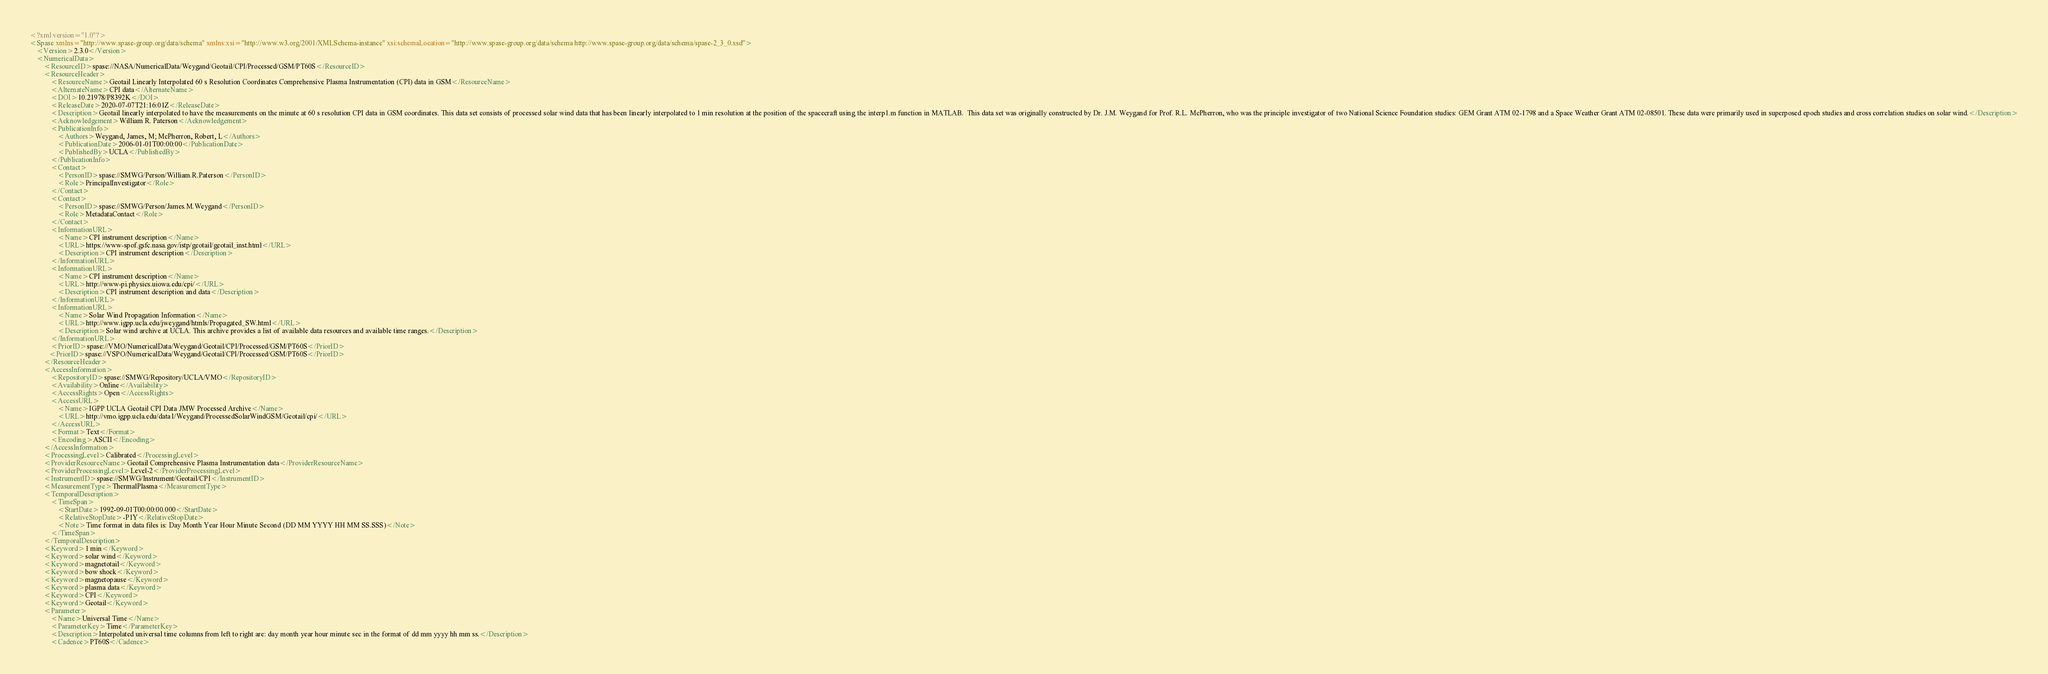Convert code to text. <code><loc_0><loc_0><loc_500><loc_500><_XML_><?xml version="1.0"?>
<Spase xmlns="http://www.spase-group.org/data/schema" xmlns:xsi="http://www.w3.org/2001/XMLSchema-instance" xsi:schemaLocation="http://www.spase-group.org/data/schema http://www.spase-group.org/data/schema/spase-2_3_0.xsd">
	<Version>2.3.0</Version>
	<NumericalData>
		<ResourceID>spase://NASA/NumericalData/Weygand/Geotail/CPI/Processed/GSM/PT60S</ResourceID>
		<ResourceHeader>
			<ResourceName>Geotail Linearly Interpolated 60 s Resolution Coordinates Comprehensive Plasma Instrumentation (CPI) data in GSM</ResourceName>
			<AlternateName>CPI data</AlternateName>
			<DOI>10.21978/P8392K</DOI>
			<ReleaseDate>2020-07-07T21:16:01Z</ReleaseDate>
			<Description>Geotail linearly interpolated to have the measurements on the minute at 60 s resolution CPI data in GSM coordinates. This data set consists of processed solar wind data that has been linearly interpolated to 1 min resolution at the position of the spacecraft using the interp1.m function in MATLAB.  This data set was originally constructed by Dr. J.M. Weygand for Prof. R.L. McPherron, who was the principle investigator of two National Science Foundation studies: GEM Grant ATM 02-1798 and a Space Weather Grant ATM 02-08501. These data were primarily used in superposed epoch studies and cross correlation studies on solar wind.</Description>
			<Acknowledgement>William R. Paterson</Acknowledgement>
			<PublicationInfo>
				<Authors>Weygand, James, M; McPherron, Robert, L</Authors>
				<PublicationDate>2006-01-01T00:00:00</PublicationDate>
				<PublishedBy>UCLA</PublishedBy>
			</PublicationInfo>
			<Contact>
				<PersonID>spase://SMWG/Person/William.R.Paterson</PersonID>
				<Role>PrincipalInvestigator</Role>
			</Contact>
			<Contact>
				<PersonID>spase://SMWG/Person/James.M.Weygand</PersonID>
				<Role>MetadataContact</Role>
			</Contact>
			<InformationURL>
				<Name>CPI instrument description</Name>
				<URL>https://www-spof.gsfc.nasa.gov/istp/geotail/geotail_inst.html</URL>
				<Description>CPI instrument description</Description>
			</InformationURL>
			<InformationURL>
				<Name>CPI instrument description</Name>
				<URL>http://www-pi.physics.uiowa.edu/cpi/</URL>
				<Description>CPI instrument description and data</Description>
			</InformationURL>
			<InformationURL>
				<Name>Solar Wind Propagation Information</Name>
				<URL>http://www.igpp.ucla.edu/jweygand/htmls/Propagated_SW.html</URL>
				<Description>Solar wind archive at UCLA. This archive provides a list of available data resources and available time ranges.</Description>
			</InformationURL>
			<PriorID>spase://VMO/NumericalData/Weygand/Geotail/CPI/Processed/GSM/PT60S</PriorID>
 		   <PriorID>spase://VSPO/NumericalData/Weygand/Geotail/CPI/Processed/GSM/PT60S</PriorID>
		</ResourceHeader>
		<AccessInformation>
			<RepositoryID>spase://SMWG/Repository/UCLA/VMO</RepositoryID>
			<Availability>Online</Availability>
			<AccessRights>Open</AccessRights>
			<AccessURL>
				<Name>IGPP UCLA Geotail CPI Data JMW Processed Archive</Name>
				<URL>http://vmo.igpp.ucla.edu/data1/Weygand/ProcessedSolarWindGSM/Geotail/cpi/</URL>
			</AccessURL>
			<Format>Text</Format>
			<Encoding>ASCII</Encoding>
		</AccessInformation>
		<ProcessingLevel>Calibrated</ProcessingLevel>
		<ProviderResourceName>Geotail Comprehensive Plasma Instrumentation data</ProviderResourceName>
		<ProviderProcessingLevel>Level-2</ProviderProcessingLevel>
		<InstrumentID>spase://SMWG/Instrument/Geotail/CPI</InstrumentID>
		<MeasurementType>ThermalPlasma</MeasurementType>
		<TemporalDescription>
			<TimeSpan>
				<StartDate>1992-09-01T00:00:00.000</StartDate>
				<RelativeStopDate>-P1Y</RelativeStopDate>
				<Note>Time format in data files is: Day Month Year Hour Minute Second (DD MM YYYY HH MM SS.SSS)</Note>
			</TimeSpan>
		</TemporalDescription>
		<Keyword>1 min</Keyword>
		<Keyword>solar wind</Keyword>
		<Keyword>magnetotail</Keyword>
		<Keyword>bow shock</Keyword>
		<Keyword>magnetopause</Keyword>
		<Keyword>plasma data</Keyword>
		<Keyword>CPI</Keyword>
		<Keyword>Geotail</Keyword>
		<Parameter>
			<Name>Universal Time</Name>
			<ParameterKey>Time</ParameterKey>
			<Description>Interpolated universal time columns from left to right are: day month year hour minute sec in the format of dd mm yyyy hh mm ss.</Description>
			<Cadence>PT60S</Cadence></code> 